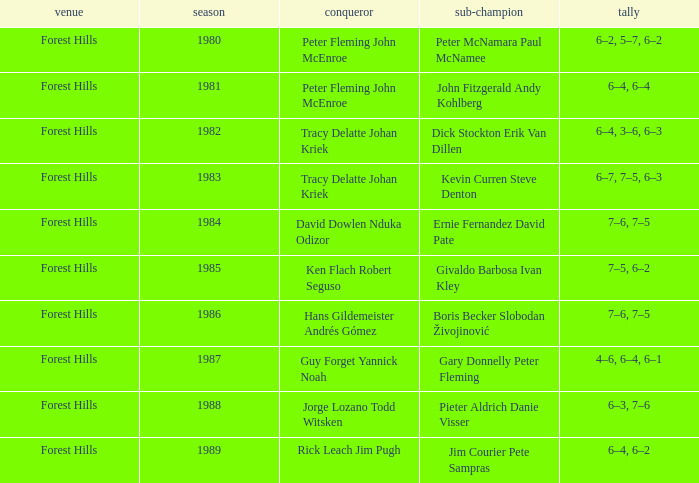Who was the runner-up in 1989? Jim Courier Pete Sampras. 